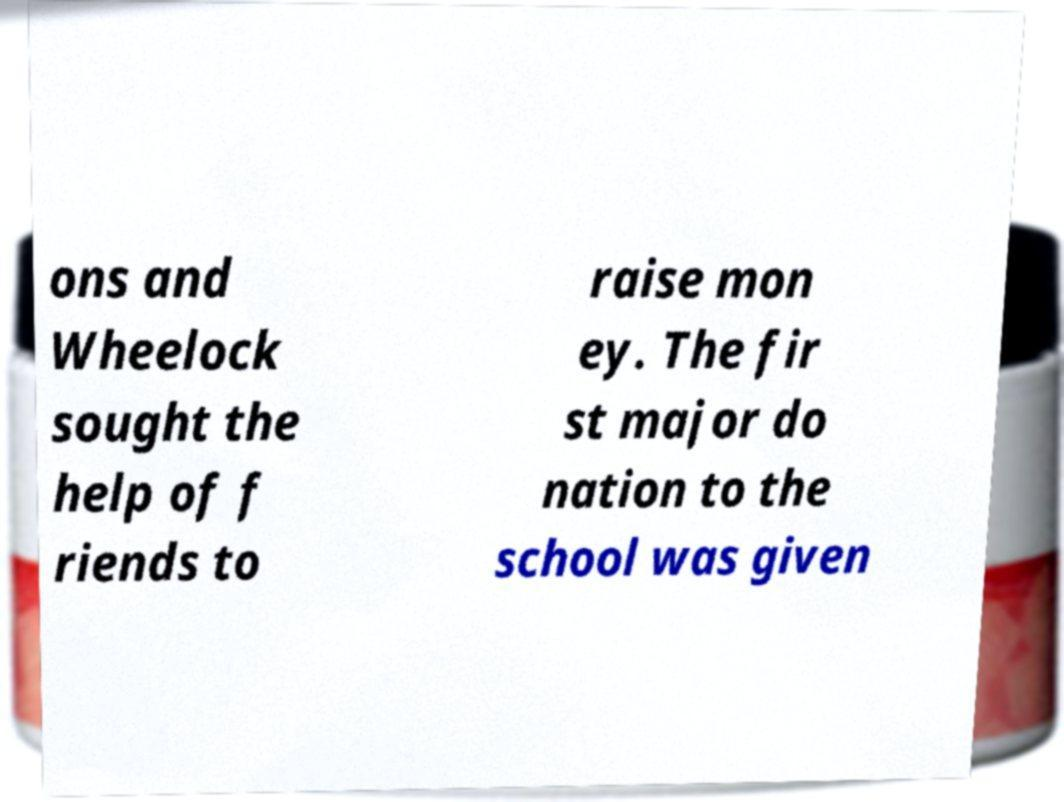I need the written content from this picture converted into text. Can you do that? ons and Wheelock sought the help of f riends to raise mon ey. The fir st major do nation to the school was given 